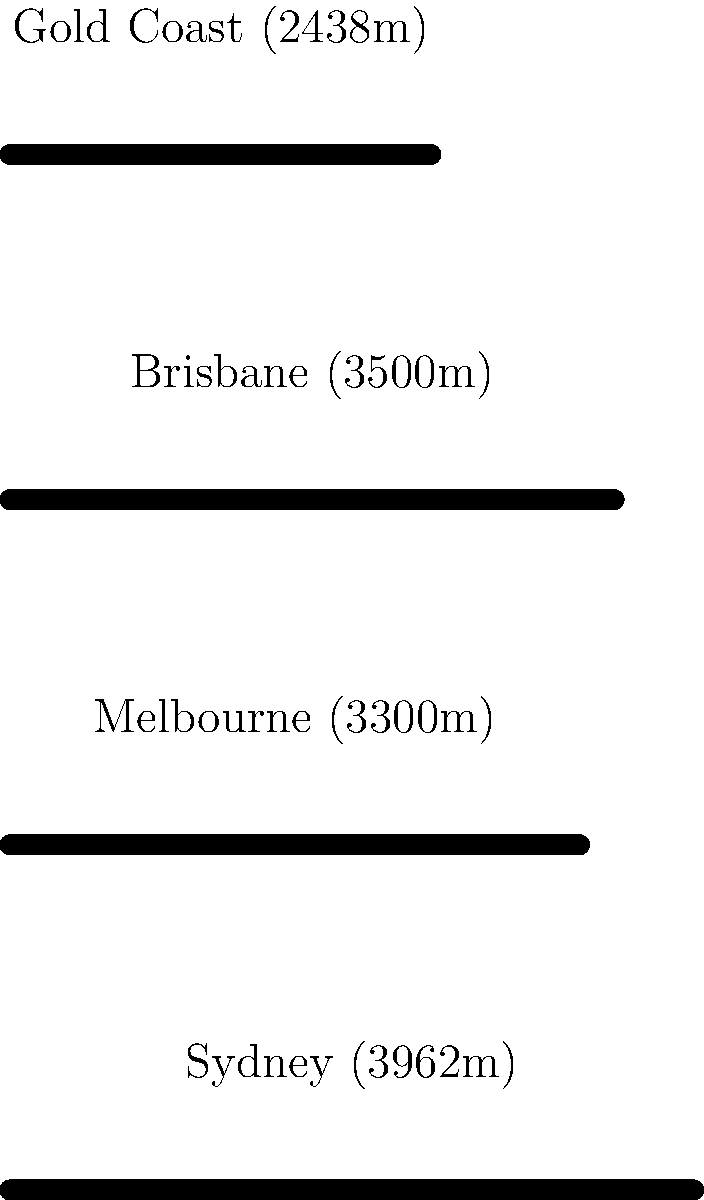Looking at the diagram of Australian airport runway lengths, which two runways appear to be most similar in size? To determine which two runways are most similar in size, we need to compare the lengths of each runway:

1. Sydney: 3962m
2. Melbourne: 3300m
3. Brisbane: 3500m
4. Gold Coast: 2438m

Step 1: Compare Sydney (3962m) with others:
- Difference with Melbourne: 3962 - 3300 = 662m
- Difference with Brisbane: 3962 - 3500 = 462m
- Difference with Gold Coast: 3962 - 2438 = 1524m

Step 2: Compare Melbourne (3300m) with Brisbane and Gold Coast:
- Difference with Brisbane: 3500 - 3300 = 200m
- Difference with Gold Coast: 3300 - 2438 = 862m

Step 3: Compare Brisbane (3500m) with Gold Coast:
- Difference: 3500 - 2438 = 1062m

The smallest difference is 200m between Melbourne and Brisbane, making them the most similar in size.
Answer: Melbourne and Brisbane 